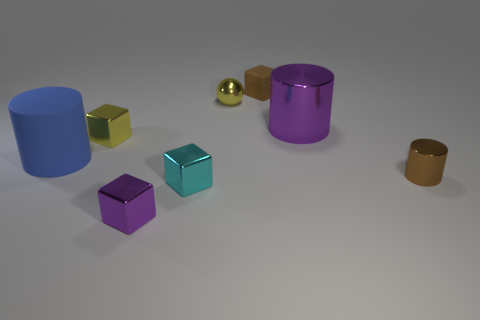Subtract all cyan metal blocks. How many blocks are left? 3 Add 2 tiny brown rubber objects. How many objects exist? 10 Subtract all cyan cubes. How many cubes are left? 3 Subtract 2 cylinders. How many cylinders are left? 1 Subtract all cyan spheres. Subtract all cyan cubes. How many spheres are left? 1 Subtract all small brown things. Subtract all small yellow cubes. How many objects are left? 5 Add 7 tiny brown matte blocks. How many tiny brown matte blocks are left? 8 Add 7 tiny yellow balls. How many tiny yellow balls exist? 8 Subtract 0 gray blocks. How many objects are left? 8 Subtract all spheres. How many objects are left? 7 